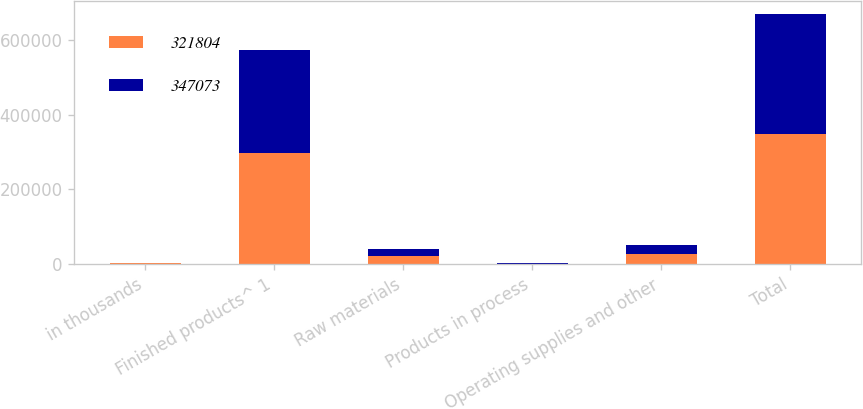Convert chart. <chart><loc_0><loc_0><loc_500><loc_500><stacked_bar_chart><ecel><fcel>in thousands<fcel>Finished products^ 1<fcel>Raw materials<fcel>Products in process<fcel>Operating supplies and other<fcel>Total<nl><fcel>321804<fcel>2015<fcel>297925<fcel>21765<fcel>1008<fcel>26375<fcel>347073<nl><fcel>347073<fcel>2014<fcel>275172<fcel>19741<fcel>1250<fcel>25641<fcel>321804<nl></chart> 